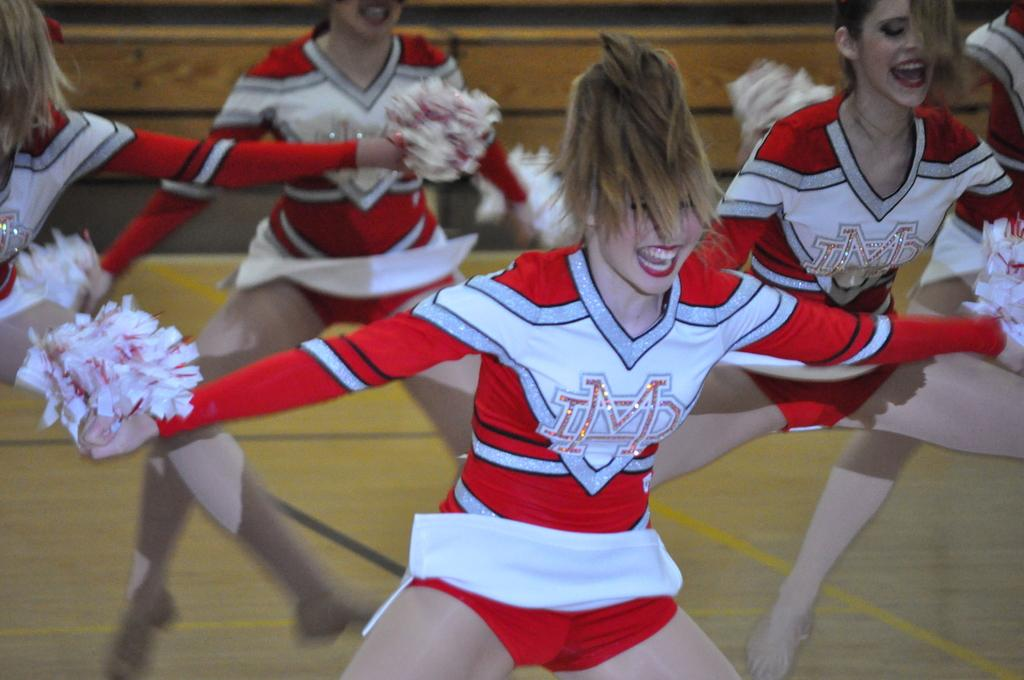Provide a one-sentence caption for the provided image. A group of cheerleaders depicting IMD logos on their uniforms as they perform. 